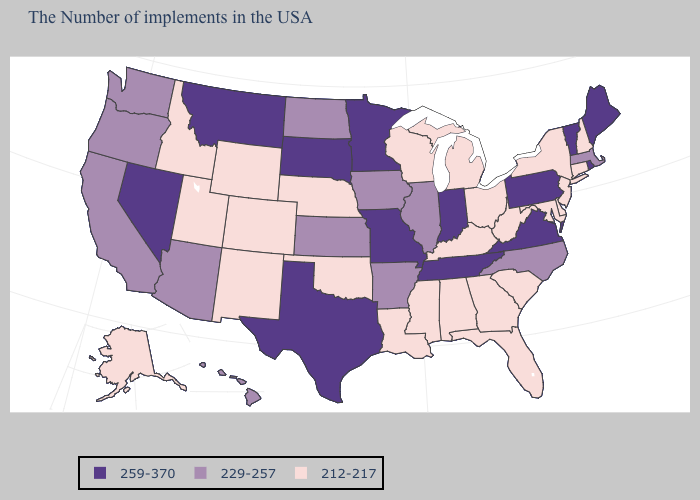Among the states that border New Mexico , does Utah have the lowest value?
Give a very brief answer. Yes. Name the states that have a value in the range 259-370?
Answer briefly. Maine, Rhode Island, Vermont, Pennsylvania, Virginia, Indiana, Tennessee, Missouri, Minnesota, Texas, South Dakota, Montana, Nevada. Is the legend a continuous bar?
Write a very short answer. No. Among the states that border New Hampshire , does Massachusetts have the lowest value?
Quick response, please. Yes. What is the lowest value in the USA?
Write a very short answer. 212-217. What is the lowest value in the MidWest?
Give a very brief answer. 212-217. Does New Jersey have the highest value in the USA?
Keep it brief. No. Does the first symbol in the legend represent the smallest category?
Quick response, please. No. Does Alabama have a lower value than Virginia?
Be succinct. Yes. Does the first symbol in the legend represent the smallest category?
Concise answer only. No. Does Virginia have the highest value in the USA?
Write a very short answer. Yes. What is the value of Rhode Island?
Keep it brief. 259-370. Name the states that have a value in the range 259-370?
Concise answer only. Maine, Rhode Island, Vermont, Pennsylvania, Virginia, Indiana, Tennessee, Missouri, Minnesota, Texas, South Dakota, Montana, Nevada. Name the states that have a value in the range 259-370?
Give a very brief answer. Maine, Rhode Island, Vermont, Pennsylvania, Virginia, Indiana, Tennessee, Missouri, Minnesota, Texas, South Dakota, Montana, Nevada. Name the states that have a value in the range 259-370?
Give a very brief answer. Maine, Rhode Island, Vermont, Pennsylvania, Virginia, Indiana, Tennessee, Missouri, Minnesota, Texas, South Dakota, Montana, Nevada. 